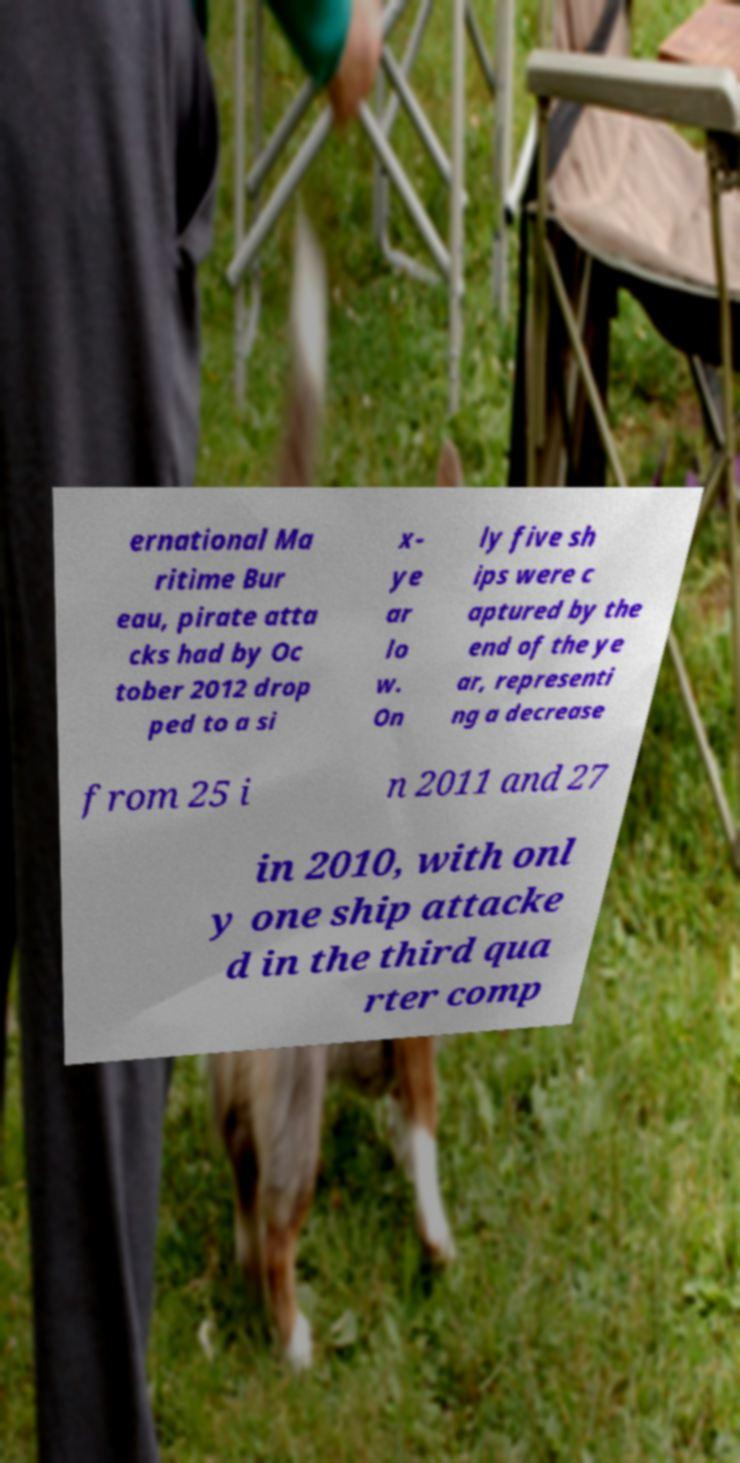Please identify and transcribe the text found in this image. ernational Ma ritime Bur eau, pirate atta cks had by Oc tober 2012 drop ped to a si x- ye ar lo w. On ly five sh ips were c aptured by the end of the ye ar, representi ng a decrease from 25 i n 2011 and 27 in 2010, with onl y one ship attacke d in the third qua rter comp 